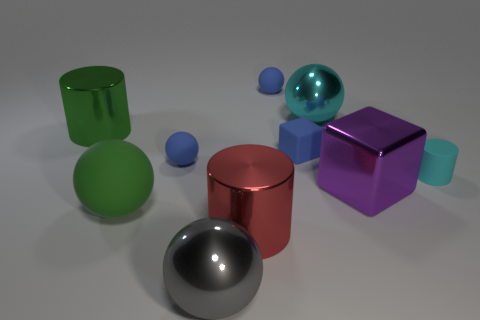Subtract all small matte cylinders. How many cylinders are left? 2 Subtract all blue cylinders. How many blue spheres are left? 2 Subtract all cyan spheres. How many spheres are left? 4 Subtract 3 balls. How many balls are left? 2 Subtract all cubes. How many objects are left? 8 Subtract all purple spheres. Subtract all brown blocks. How many spheres are left? 5 Add 6 large blue objects. How many large blue objects exist? 6 Subtract 0 red balls. How many objects are left? 10 Subtract all tiny cyan rubber cylinders. Subtract all green rubber balls. How many objects are left? 8 Add 9 large green rubber objects. How many large green rubber objects are left? 10 